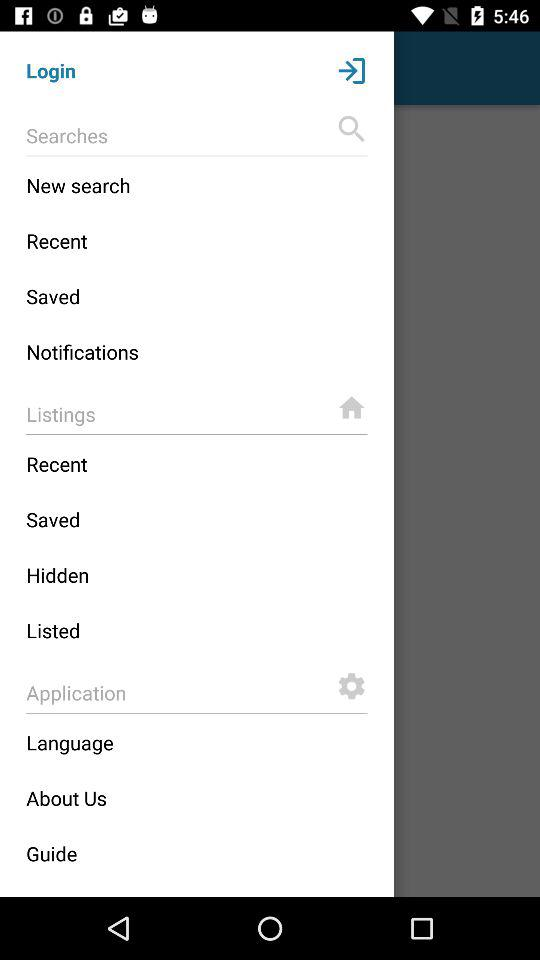What are the options available in the search option? The available options are "New search", "Recent", "Saved" and "Notifications". 